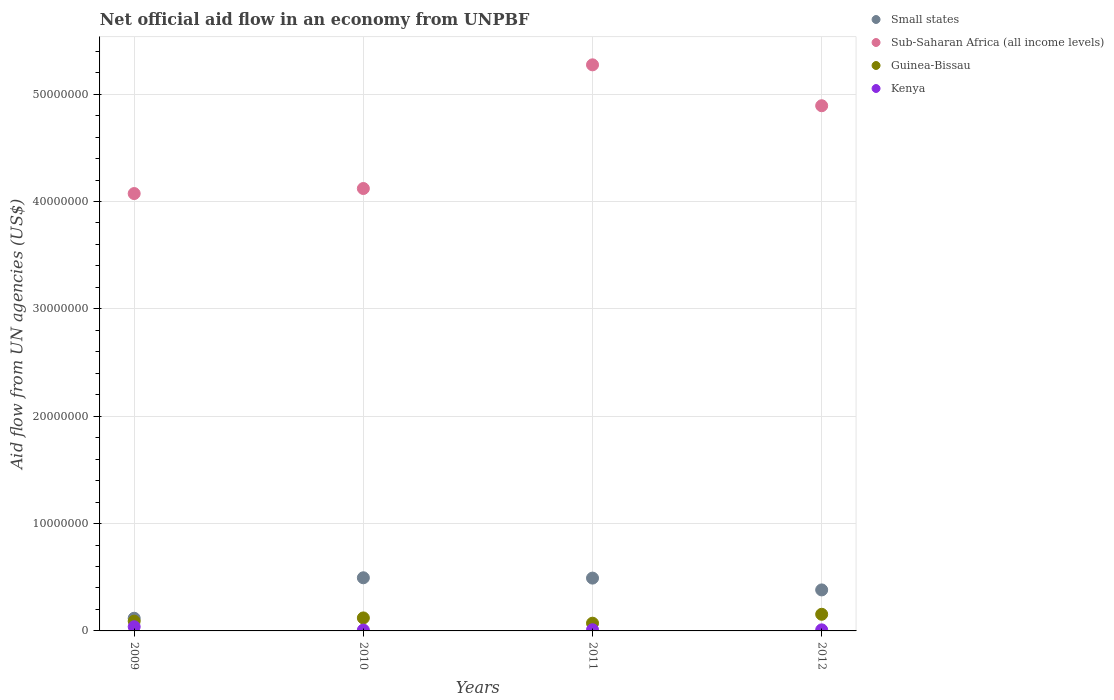How many different coloured dotlines are there?
Offer a very short reply. 4. What is the net official aid flow in Guinea-Bissau in 2009?
Keep it short and to the point. 9.10e+05. Across all years, what is the maximum net official aid flow in Small states?
Ensure brevity in your answer.  4.95e+06. Across all years, what is the minimum net official aid flow in Small states?
Your response must be concise. 1.18e+06. What is the total net official aid flow in Sub-Saharan Africa (all income levels) in the graph?
Provide a succinct answer. 1.84e+08. What is the difference between the net official aid flow in Small states in 2009 and that in 2011?
Ensure brevity in your answer.  -3.74e+06. What is the difference between the net official aid flow in Guinea-Bissau in 2011 and the net official aid flow in Sub-Saharan Africa (all income levels) in 2009?
Provide a short and direct response. -4.00e+07. What is the average net official aid flow in Sub-Saharan Africa (all income levels) per year?
Offer a very short reply. 4.59e+07. In the year 2012, what is the difference between the net official aid flow in Kenya and net official aid flow in Sub-Saharan Africa (all income levels)?
Offer a very short reply. -4.88e+07. In how many years, is the net official aid flow in Sub-Saharan Africa (all income levels) greater than 8000000 US$?
Keep it short and to the point. 4. What is the ratio of the net official aid flow in Kenya in 2010 to that in 2011?
Ensure brevity in your answer.  0.73. What is the difference between the highest and the lowest net official aid flow in Guinea-Bissau?
Ensure brevity in your answer.  8.30e+05. In how many years, is the net official aid flow in Guinea-Bissau greater than the average net official aid flow in Guinea-Bissau taken over all years?
Give a very brief answer. 2. Is the sum of the net official aid flow in Kenya in 2010 and 2012 greater than the maximum net official aid flow in Guinea-Bissau across all years?
Provide a succinct answer. No. Is it the case that in every year, the sum of the net official aid flow in Kenya and net official aid flow in Small states  is greater than the sum of net official aid flow in Sub-Saharan Africa (all income levels) and net official aid flow in Guinea-Bissau?
Make the answer very short. No. Is it the case that in every year, the sum of the net official aid flow in Small states and net official aid flow in Guinea-Bissau  is greater than the net official aid flow in Sub-Saharan Africa (all income levels)?
Provide a short and direct response. No. Does the net official aid flow in Guinea-Bissau monotonically increase over the years?
Provide a succinct answer. No. How many dotlines are there?
Ensure brevity in your answer.  4. How many years are there in the graph?
Your answer should be very brief. 4. What is the difference between two consecutive major ticks on the Y-axis?
Provide a short and direct response. 1.00e+07. Are the values on the major ticks of Y-axis written in scientific E-notation?
Provide a succinct answer. No. Does the graph contain grids?
Offer a terse response. Yes. Where does the legend appear in the graph?
Provide a short and direct response. Top right. How many legend labels are there?
Offer a terse response. 4. How are the legend labels stacked?
Provide a short and direct response. Vertical. What is the title of the graph?
Your answer should be compact. Net official aid flow in an economy from UNPBF. Does "Pakistan" appear as one of the legend labels in the graph?
Make the answer very short. No. What is the label or title of the Y-axis?
Ensure brevity in your answer.  Aid flow from UN agencies (US$). What is the Aid flow from UN agencies (US$) of Small states in 2009?
Offer a very short reply. 1.18e+06. What is the Aid flow from UN agencies (US$) of Sub-Saharan Africa (all income levels) in 2009?
Offer a terse response. 4.07e+07. What is the Aid flow from UN agencies (US$) of Guinea-Bissau in 2009?
Your answer should be very brief. 9.10e+05. What is the Aid flow from UN agencies (US$) of Small states in 2010?
Your answer should be compact. 4.95e+06. What is the Aid flow from UN agencies (US$) in Sub-Saharan Africa (all income levels) in 2010?
Give a very brief answer. 4.12e+07. What is the Aid flow from UN agencies (US$) of Guinea-Bissau in 2010?
Keep it short and to the point. 1.21e+06. What is the Aid flow from UN agencies (US$) of Small states in 2011?
Give a very brief answer. 4.92e+06. What is the Aid flow from UN agencies (US$) in Sub-Saharan Africa (all income levels) in 2011?
Provide a succinct answer. 5.27e+07. What is the Aid flow from UN agencies (US$) in Guinea-Bissau in 2011?
Keep it short and to the point. 7.20e+05. What is the Aid flow from UN agencies (US$) of Small states in 2012?
Give a very brief answer. 3.82e+06. What is the Aid flow from UN agencies (US$) in Sub-Saharan Africa (all income levels) in 2012?
Provide a succinct answer. 4.89e+07. What is the Aid flow from UN agencies (US$) of Guinea-Bissau in 2012?
Provide a short and direct response. 1.55e+06. Across all years, what is the maximum Aid flow from UN agencies (US$) of Small states?
Provide a succinct answer. 4.95e+06. Across all years, what is the maximum Aid flow from UN agencies (US$) in Sub-Saharan Africa (all income levels)?
Offer a very short reply. 5.27e+07. Across all years, what is the maximum Aid flow from UN agencies (US$) of Guinea-Bissau?
Provide a succinct answer. 1.55e+06. Across all years, what is the maximum Aid flow from UN agencies (US$) in Kenya?
Provide a short and direct response. 3.90e+05. Across all years, what is the minimum Aid flow from UN agencies (US$) of Small states?
Provide a short and direct response. 1.18e+06. Across all years, what is the minimum Aid flow from UN agencies (US$) in Sub-Saharan Africa (all income levels)?
Provide a short and direct response. 4.07e+07. Across all years, what is the minimum Aid flow from UN agencies (US$) in Guinea-Bissau?
Keep it short and to the point. 7.20e+05. Across all years, what is the minimum Aid flow from UN agencies (US$) in Kenya?
Offer a terse response. 8.00e+04. What is the total Aid flow from UN agencies (US$) in Small states in the graph?
Ensure brevity in your answer.  1.49e+07. What is the total Aid flow from UN agencies (US$) of Sub-Saharan Africa (all income levels) in the graph?
Your answer should be compact. 1.84e+08. What is the total Aid flow from UN agencies (US$) in Guinea-Bissau in the graph?
Offer a terse response. 4.39e+06. What is the total Aid flow from UN agencies (US$) of Kenya in the graph?
Offer a terse response. 6.80e+05. What is the difference between the Aid flow from UN agencies (US$) in Small states in 2009 and that in 2010?
Make the answer very short. -3.77e+06. What is the difference between the Aid flow from UN agencies (US$) of Sub-Saharan Africa (all income levels) in 2009 and that in 2010?
Make the answer very short. -4.70e+05. What is the difference between the Aid flow from UN agencies (US$) of Guinea-Bissau in 2009 and that in 2010?
Offer a very short reply. -3.00e+05. What is the difference between the Aid flow from UN agencies (US$) of Small states in 2009 and that in 2011?
Provide a short and direct response. -3.74e+06. What is the difference between the Aid flow from UN agencies (US$) in Sub-Saharan Africa (all income levels) in 2009 and that in 2011?
Offer a terse response. -1.20e+07. What is the difference between the Aid flow from UN agencies (US$) of Small states in 2009 and that in 2012?
Ensure brevity in your answer.  -2.64e+06. What is the difference between the Aid flow from UN agencies (US$) of Sub-Saharan Africa (all income levels) in 2009 and that in 2012?
Your answer should be compact. -8.18e+06. What is the difference between the Aid flow from UN agencies (US$) in Guinea-Bissau in 2009 and that in 2012?
Your response must be concise. -6.40e+05. What is the difference between the Aid flow from UN agencies (US$) of Kenya in 2009 and that in 2012?
Provide a short and direct response. 2.90e+05. What is the difference between the Aid flow from UN agencies (US$) in Small states in 2010 and that in 2011?
Make the answer very short. 3.00e+04. What is the difference between the Aid flow from UN agencies (US$) in Sub-Saharan Africa (all income levels) in 2010 and that in 2011?
Provide a succinct answer. -1.15e+07. What is the difference between the Aid flow from UN agencies (US$) of Kenya in 2010 and that in 2011?
Your answer should be compact. -3.00e+04. What is the difference between the Aid flow from UN agencies (US$) of Small states in 2010 and that in 2012?
Keep it short and to the point. 1.13e+06. What is the difference between the Aid flow from UN agencies (US$) in Sub-Saharan Africa (all income levels) in 2010 and that in 2012?
Provide a short and direct response. -7.71e+06. What is the difference between the Aid flow from UN agencies (US$) of Kenya in 2010 and that in 2012?
Provide a short and direct response. -2.00e+04. What is the difference between the Aid flow from UN agencies (US$) of Small states in 2011 and that in 2012?
Your answer should be compact. 1.10e+06. What is the difference between the Aid flow from UN agencies (US$) in Sub-Saharan Africa (all income levels) in 2011 and that in 2012?
Your answer should be very brief. 3.81e+06. What is the difference between the Aid flow from UN agencies (US$) in Guinea-Bissau in 2011 and that in 2012?
Your response must be concise. -8.30e+05. What is the difference between the Aid flow from UN agencies (US$) of Small states in 2009 and the Aid flow from UN agencies (US$) of Sub-Saharan Africa (all income levels) in 2010?
Make the answer very short. -4.00e+07. What is the difference between the Aid flow from UN agencies (US$) in Small states in 2009 and the Aid flow from UN agencies (US$) in Kenya in 2010?
Offer a terse response. 1.10e+06. What is the difference between the Aid flow from UN agencies (US$) in Sub-Saharan Africa (all income levels) in 2009 and the Aid flow from UN agencies (US$) in Guinea-Bissau in 2010?
Offer a very short reply. 3.95e+07. What is the difference between the Aid flow from UN agencies (US$) of Sub-Saharan Africa (all income levels) in 2009 and the Aid flow from UN agencies (US$) of Kenya in 2010?
Make the answer very short. 4.07e+07. What is the difference between the Aid flow from UN agencies (US$) in Guinea-Bissau in 2009 and the Aid flow from UN agencies (US$) in Kenya in 2010?
Your response must be concise. 8.30e+05. What is the difference between the Aid flow from UN agencies (US$) of Small states in 2009 and the Aid flow from UN agencies (US$) of Sub-Saharan Africa (all income levels) in 2011?
Provide a succinct answer. -5.16e+07. What is the difference between the Aid flow from UN agencies (US$) of Small states in 2009 and the Aid flow from UN agencies (US$) of Guinea-Bissau in 2011?
Your answer should be very brief. 4.60e+05. What is the difference between the Aid flow from UN agencies (US$) in Small states in 2009 and the Aid flow from UN agencies (US$) in Kenya in 2011?
Provide a succinct answer. 1.07e+06. What is the difference between the Aid flow from UN agencies (US$) in Sub-Saharan Africa (all income levels) in 2009 and the Aid flow from UN agencies (US$) in Guinea-Bissau in 2011?
Give a very brief answer. 4.00e+07. What is the difference between the Aid flow from UN agencies (US$) of Sub-Saharan Africa (all income levels) in 2009 and the Aid flow from UN agencies (US$) of Kenya in 2011?
Your response must be concise. 4.06e+07. What is the difference between the Aid flow from UN agencies (US$) of Small states in 2009 and the Aid flow from UN agencies (US$) of Sub-Saharan Africa (all income levels) in 2012?
Offer a terse response. -4.77e+07. What is the difference between the Aid flow from UN agencies (US$) in Small states in 2009 and the Aid flow from UN agencies (US$) in Guinea-Bissau in 2012?
Your answer should be compact. -3.70e+05. What is the difference between the Aid flow from UN agencies (US$) of Small states in 2009 and the Aid flow from UN agencies (US$) of Kenya in 2012?
Your answer should be compact. 1.08e+06. What is the difference between the Aid flow from UN agencies (US$) in Sub-Saharan Africa (all income levels) in 2009 and the Aid flow from UN agencies (US$) in Guinea-Bissau in 2012?
Make the answer very short. 3.92e+07. What is the difference between the Aid flow from UN agencies (US$) of Sub-Saharan Africa (all income levels) in 2009 and the Aid flow from UN agencies (US$) of Kenya in 2012?
Your response must be concise. 4.06e+07. What is the difference between the Aid flow from UN agencies (US$) in Guinea-Bissau in 2009 and the Aid flow from UN agencies (US$) in Kenya in 2012?
Provide a short and direct response. 8.10e+05. What is the difference between the Aid flow from UN agencies (US$) in Small states in 2010 and the Aid flow from UN agencies (US$) in Sub-Saharan Africa (all income levels) in 2011?
Make the answer very short. -4.78e+07. What is the difference between the Aid flow from UN agencies (US$) of Small states in 2010 and the Aid flow from UN agencies (US$) of Guinea-Bissau in 2011?
Provide a short and direct response. 4.23e+06. What is the difference between the Aid flow from UN agencies (US$) of Small states in 2010 and the Aid flow from UN agencies (US$) of Kenya in 2011?
Provide a succinct answer. 4.84e+06. What is the difference between the Aid flow from UN agencies (US$) of Sub-Saharan Africa (all income levels) in 2010 and the Aid flow from UN agencies (US$) of Guinea-Bissau in 2011?
Make the answer very short. 4.05e+07. What is the difference between the Aid flow from UN agencies (US$) in Sub-Saharan Africa (all income levels) in 2010 and the Aid flow from UN agencies (US$) in Kenya in 2011?
Offer a terse response. 4.11e+07. What is the difference between the Aid flow from UN agencies (US$) in Guinea-Bissau in 2010 and the Aid flow from UN agencies (US$) in Kenya in 2011?
Provide a short and direct response. 1.10e+06. What is the difference between the Aid flow from UN agencies (US$) in Small states in 2010 and the Aid flow from UN agencies (US$) in Sub-Saharan Africa (all income levels) in 2012?
Your answer should be compact. -4.40e+07. What is the difference between the Aid flow from UN agencies (US$) of Small states in 2010 and the Aid flow from UN agencies (US$) of Guinea-Bissau in 2012?
Your answer should be very brief. 3.40e+06. What is the difference between the Aid flow from UN agencies (US$) of Small states in 2010 and the Aid flow from UN agencies (US$) of Kenya in 2012?
Make the answer very short. 4.85e+06. What is the difference between the Aid flow from UN agencies (US$) of Sub-Saharan Africa (all income levels) in 2010 and the Aid flow from UN agencies (US$) of Guinea-Bissau in 2012?
Give a very brief answer. 3.97e+07. What is the difference between the Aid flow from UN agencies (US$) in Sub-Saharan Africa (all income levels) in 2010 and the Aid flow from UN agencies (US$) in Kenya in 2012?
Keep it short and to the point. 4.11e+07. What is the difference between the Aid flow from UN agencies (US$) in Guinea-Bissau in 2010 and the Aid flow from UN agencies (US$) in Kenya in 2012?
Make the answer very short. 1.11e+06. What is the difference between the Aid flow from UN agencies (US$) in Small states in 2011 and the Aid flow from UN agencies (US$) in Sub-Saharan Africa (all income levels) in 2012?
Your answer should be very brief. -4.40e+07. What is the difference between the Aid flow from UN agencies (US$) of Small states in 2011 and the Aid flow from UN agencies (US$) of Guinea-Bissau in 2012?
Offer a very short reply. 3.37e+06. What is the difference between the Aid flow from UN agencies (US$) of Small states in 2011 and the Aid flow from UN agencies (US$) of Kenya in 2012?
Ensure brevity in your answer.  4.82e+06. What is the difference between the Aid flow from UN agencies (US$) in Sub-Saharan Africa (all income levels) in 2011 and the Aid flow from UN agencies (US$) in Guinea-Bissau in 2012?
Your answer should be very brief. 5.12e+07. What is the difference between the Aid flow from UN agencies (US$) of Sub-Saharan Africa (all income levels) in 2011 and the Aid flow from UN agencies (US$) of Kenya in 2012?
Give a very brief answer. 5.26e+07. What is the difference between the Aid flow from UN agencies (US$) in Guinea-Bissau in 2011 and the Aid flow from UN agencies (US$) in Kenya in 2012?
Offer a very short reply. 6.20e+05. What is the average Aid flow from UN agencies (US$) in Small states per year?
Your answer should be compact. 3.72e+06. What is the average Aid flow from UN agencies (US$) in Sub-Saharan Africa (all income levels) per year?
Offer a very short reply. 4.59e+07. What is the average Aid flow from UN agencies (US$) of Guinea-Bissau per year?
Your answer should be very brief. 1.10e+06. In the year 2009, what is the difference between the Aid flow from UN agencies (US$) in Small states and Aid flow from UN agencies (US$) in Sub-Saharan Africa (all income levels)?
Make the answer very short. -3.96e+07. In the year 2009, what is the difference between the Aid flow from UN agencies (US$) of Small states and Aid flow from UN agencies (US$) of Kenya?
Provide a short and direct response. 7.90e+05. In the year 2009, what is the difference between the Aid flow from UN agencies (US$) in Sub-Saharan Africa (all income levels) and Aid flow from UN agencies (US$) in Guinea-Bissau?
Give a very brief answer. 3.98e+07. In the year 2009, what is the difference between the Aid flow from UN agencies (US$) of Sub-Saharan Africa (all income levels) and Aid flow from UN agencies (US$) of Kenya?
Your answer should be compact. 4.04e+07. In the year 2009, what is the difference between the Aid flow from UN agencies (US$) in Guinea-Bissau and Aid flow from UN agencies (US$) in Kenya?
Provide a short and direct response. 5.20e+05. In the year 2010, what is the difference between the Aid flow from UN agencies (US$) of Small states and Aid flow from UN agencies (US$) of Sub-Saharan Africa (all income levels)?
Make the answer very short. -3.63e+07. In the year 2010, what is the difference between the Aid flow from UN agencies (US$) in Small states and Aid flow from UN agencies (US$) in Guinea-Bissau?
Provide a succinct answer. 3.74e+06. In the year 2010, what is the difference between the Aid flow from UN agencies (US$) of Small states and Aid flow from UN agencies (US$) of Kenya?
Your response must be concise. 4.87e+06. In the year 2010, what is the difference between the Aid flow from UN agencies (US$) in Sub-Saharan Africa (all income levels) and Aid flow from UN agencies (US$) in Guinea-Bissau?
Provide a succinct answer. 4.00e+07. In the year 2010, what is the difference between the Aid flow from UN agencies (US$) of Sub-Saharan Africa (all income levels) and Aid flow from UN agencies (US$) of Kenya?
Your answer should be compact. 4.11e+07. In the year 2010, what is the difference between the Aid flow from UN agencies (US$) of Guinea-Bissau and Aid flow from UN agencies (US$) of Kenya?
Provide a short and direct response. 1.13e+06. In the year 2011, what is the difference between the Aid flow from UN agencies (US$) of Small states and Aid flow from UN agencies (US$) of Sub-Saharan Africa (all income levels)?
Provide a short and direct response. -4.78e+07. In the year 2011, what is the difference between the Aid flow from UN agencies (US$) in Small states and Aid flow from UN agencies (US$) in Guinea-Bissau?
Your answer should be compact. 4.20e+06. In the year 2011, what is the difference between the Aid flow from UN agencies (US$) of Small states and Aid flow from UN agencies (US$) of Kenya?
Make the answer very short. 4.81e+06. In the year 2011, what is the difference between the Aid flow from UN agencies (US$) in Sub-Saharan Africa (all income levels) and Aid flow from UN agencies (US$) in Guinea-Bissau?
Provide a short and direct response. 5.20e+07. In the year 2011, what is the difference between the Aid flow from UN agencies (US$) in Sub-Saharan Africa (all income levels) and Aid flow from UN agencies (US$) in Kenya?
Offer a terse response. 5.26e+07. In the year 2011, what is the difference between the Aid flow from UN agencies (US$) in Guinea-Bissau and Aid flow from UN agencies (US$) in Kenya?
Give a very brief answer. 6.10e+05. In the year 2012, what is the difference between the Aid flow from UN agencies (US$) of Small states and Aid flow from UN agencies (US$) of Sub-Saharan Africa (all income levels)?
Your answer should be compact. -4.51e+07. In the year 2012, what is the difference between the Aid flow from UN agencies (US$) of Small states and Aid flow from UN agencies (US$) of Guinea-Bissau?
Offer a terse response. 2.27e+06. In the year 2012, what is the difference between the Aid flow from UN agencies (US$) of Small states and Aid flow from UN agencies (US$) of Kenya?
Make the answer very short. 3.72e+06. In the year 2012, what is the difference between the Aid flow from UN agencies (US$) of Sub-Saharan Africa (all income levels) and Aid flow from UN agencies (US$) of Guinea-Bissau?
Your answer should be compact. 4.74e+07. In the year 2012, what is the difference between the Aid flow from UN agencies (US$) of Sub-Saharan Africa (all income levels) and Aid flow from UN agencies (US$) of Kenya?
Provide a succinct answer. 4.88e+07. In the year 2012, what is the difference between the Aid flow from UN agencies (US$) of Guinea-Bissau and Aid flow from UN agencies (US$) of Kenya?
Provide a short and direct response. 1.45e+06. What is the ratio of the Aid flow from UN agencies (US$) of Small states in 2009 to that in 2010?
Provide a succinct answer. 0.24. What is the ratio of the Aid flow from UN agencies (US$) of Guinea-Bissau in 2009 to that in 2010?
Your answer should be very brief. 0.75. What is the ratio of the Aid flow from UN agencies (US$) in Kenya in 2009 to that in 2010?
Give a very brief answer. 4.88. What is the ratio of the Aid flow from UN agencies (US$) in Small states in 2009 to that in 2011?
Provide a short and direct response. 0.24. What is the ratio of the Aid flow from UN agencies (US$) of Sub-Saharan Africa (all income levels) in 2009 to that in 2011?
Offer a terse response. 0.77. What is the ratio of the Aid flow from UN agencies (US$) in Guinea-Bissau in 2009 to that in 2011?
Offer a terse response. 1.26. What is the ratio of the Aid flow from UN agencies (US$) in Kenya in 2009 to that in 2011?
Your response must be concise. 3.55. What is the ratio of the Aid flow from UN agencies (US$) of Small states in 2009 to that in 2012?
Ensure brevity in your answer.  0.31. What is the ratio of the Aid flow from UN agencies (US$) in Sub-Saharan Africa (all income levels) in 2009 to that in 2012?
Make the answer very short. 0.83. What is the ratio of the Aid flow from UN agencies (US$) in Guinea-Bissau in 2009 to that in 2012?
Your response must be concise. 0.59. What is the ratio of the Aid flow from UN agencies (US$) in Kenya in 2009 to that in 2012?
Make the answer very short. 3.9. What is the ratio of the Aid flow from UN agencies (US$) in Small states in 2010 to that in 2011?
Your answer should be compact. 1.01. What is the ratio of the Aid flow from UN agencies (US$) in Sub-Saharan Africa (all income levels) in 2010 to that in 2011?
Give a very brief answer. 0.78. What is the ratio of the Aid flow from UN agencies (US$) in Guinea-Bissau in 2010 to that in 2011?
Provide a succinct answer. 1.68. What is the ratio of the Aid flow from UN agencies (US$) in Kenya in 2010 to that in 2011?
Your answer should be very brief. 0.73. What is the ratio of the Aid flow from UN agencies (US$) of Small states in 2010 to that in 2012?
Keep it short and to the point. 1.3. What is the ratio of the Aid flow from UN agencies (US$) in Sub-Saharan Africa (all income levels) in 2010 to that in 2012?
Ensure brevity in your answer.  0.84. What is the ratio of the Aid flow from UN agencies (US$) in Guinea-Bissau in 2010 to that in 2012?
Give a very brief answer. 0.78. What is the ratio of the Aid flow from UN agencies (US$) in Small states in 2011 to that in 2012?
Your answer should be compact. 1.29. What is the ratio of the Aid flow from UN agencies (US$) in Sub-Saharan Africa (all income levels) in 2011 to that in 2012?
Offer a very short reply. 1.08. What is the ratio of the Aid flow from UN agencies (US$) in Guinea-Bissau in 2011 to that in 2012?
Provide a short and direct response. 0.46. What is the difference between the highest and the second highest Aid flow from UN agencies (US$) of Sub-Saharan Africa (all income levels)?
Your answer should be compact. 3.81e+06. What is the difference between the highest and the second highest Aid flow from UN agencies (US$) in Guinea-Bissau?
Provide a short and direct response. 3.40e+05. What is the difference between the highest and the second highest Aid flow from UN agencies (US$) in Kenya?
Ensure brevity in your answer.  2.80e+05. What is the difference between the highest and the lowest Aid flow from UN agencies (US$) of Small states?
Give a very brief answer. 3.77e+06. What is the difference between the highest and the lowest Aid flow from UN agencies (US$) of Sub-Saharan Africa (all income levels)?
Offer a very short reply. 1.20e+07. What is the difference between the highest and the lowest Aid flow from UN agencies (US$) in Guinea-Bissau?
Your answer should be very brief. 8.30e+05. What is the difference between the highest and the lowest Aid flow from UN agencies (US$) of Kenya?
Keep it short and to the point. 3.10e+05. 